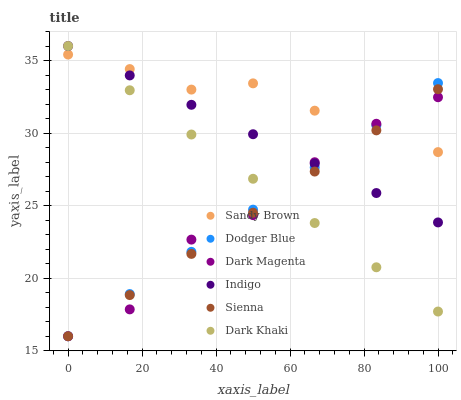Does Sienna have the minimum area under the curve?
Answer yes or no. Yes. Does Sandy Brown have the maximum area under the curve?
Answer yes or no. Yes. Does Indigo have the minimum area under the curve?
Answer yes or no. No. Does Indigo have the maximum area under the curve?
Answer yes or no. No. Is Dark Khaki the smoothest?
Answer yes or no. Yes. Is Dark Magenta the roughest?
Answer yes or no. Yes. Is Indigo the smoothest?
Answer yes or no. No. Is Indigo the roughest?
Answer yes or no. No. Does Dark Magenta have the lowest value?
Answer yes or no. Yes. Does Indigo have the lowest value?
Answer yes or no. No. Does Indigo have the highest value?
Answer yes or no. Yes. Does Dark Magenta have the highest value?
Answer yes or no. No. Does Indigo intersect Dark Khaki?
Answer yes or no. Yes. Is Indigo less than Dark Khaki?
Answer yes or no. No. Is Indigo greater than Dark Khaki?
Answer yes or no. No. 